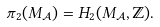<formula> <loc_0><loc_0><loc_500><loc_500>\pi _ { 2 } ( M _ { \mathcal { A } } ) = H _ { 2 } ( M _ { \mathcal { A } } , \mathbb { Z } ) .</formula> 